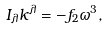<formula> <loc_0><loc_0><loc_500><loc_500>I _ { \lambda } k ^ { \lambda } = - f _ { 2 } \omega ^ { 3 } ,</formula> 